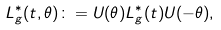<formula> <loc_0><loc_0><loc_500><loc_500>L ^ { * } _ { g } ( t , \theta ) \colon = U ( \theta ) L ^ { * } _ { g } ( t ) U ( - \theta ) ,</formula> 